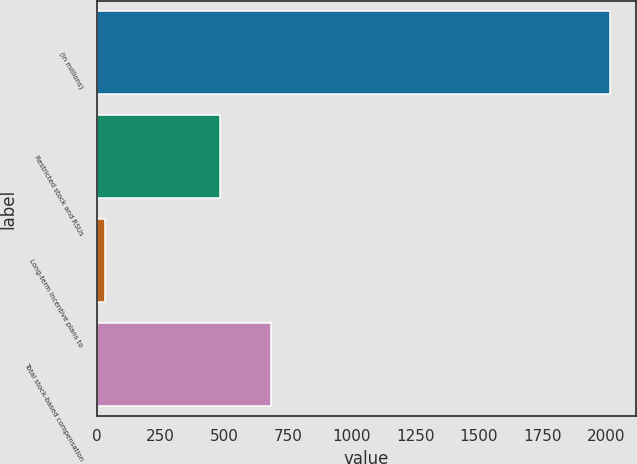<chart> <loc_0><loc_0><loc_500><loc_500><bar_chart><fcel>(in millions)<fcel>Restricted stock and RSUs<fcel>Long-term incentive plans to<fcel>Total stock-based compensation<nl><fcel>2015<fcel>484<fcel>30<fcel>682.5<nl></chart> 